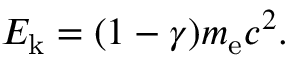Convert formula to latex. <formula><loc_0><loc_0><loc_500><loc_500>E _ { k } = ( 1 - \gamma ) m _ { e } c ^ { 2 } .</formula> 